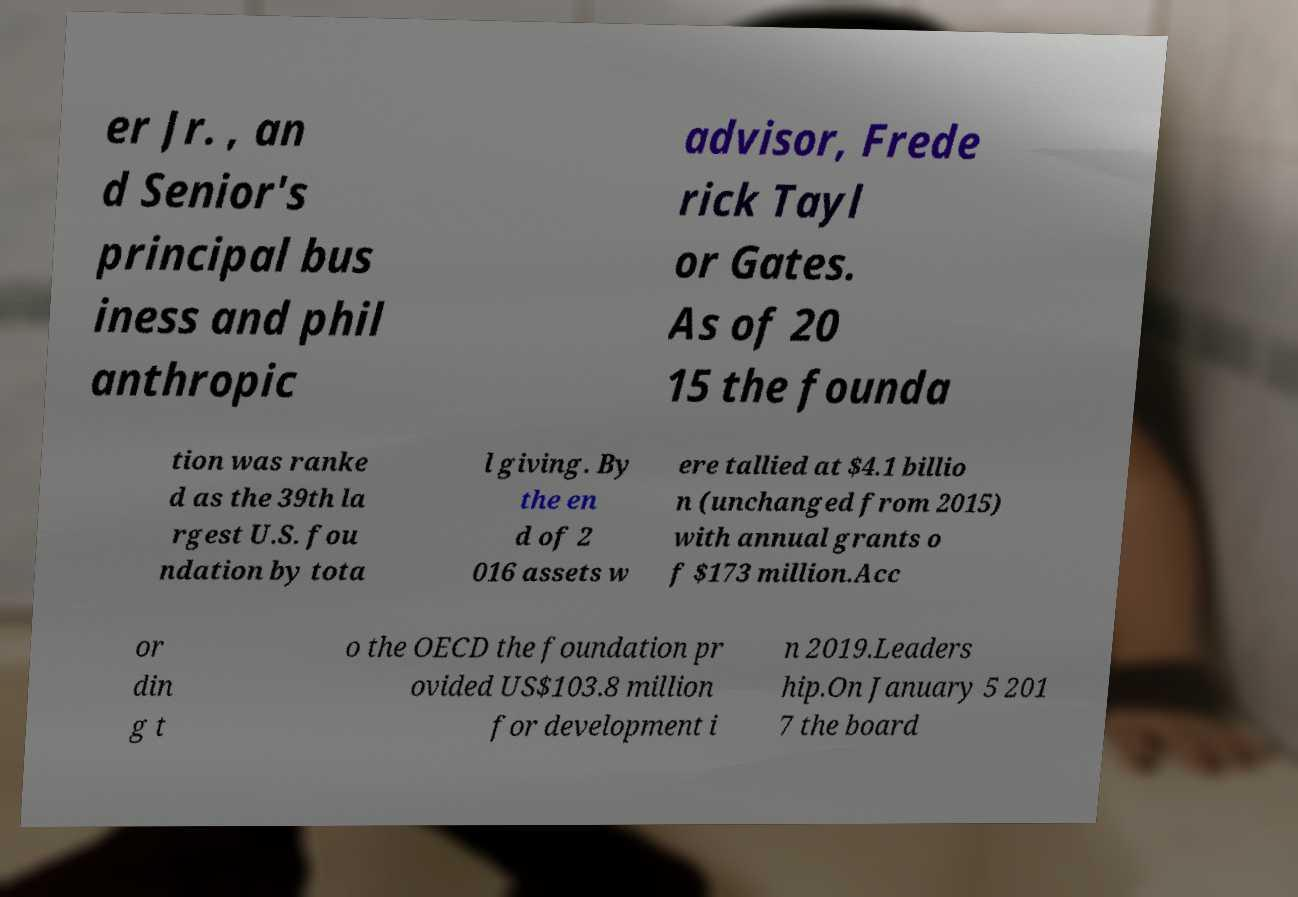I need the written content from this picture converted into text. Can you do that? er Jr. , an d Senior's principal bus iness and phil anthropic advisor, Frede rick Tayl or Gates. As of 20 15 the founda tion was ranke d as the 39th la rgest U.S. fou ndation by tota l giving. By the en d of 2 016 assets w ere tallied at $4.1 billio n (unchanged from 2015) with annual grants o f $173 million.Acc or din g t o the OECD the foundation pr ovided US$103.8 million for development i n 2019.Leaders hip.On January 5 201 7 the board 